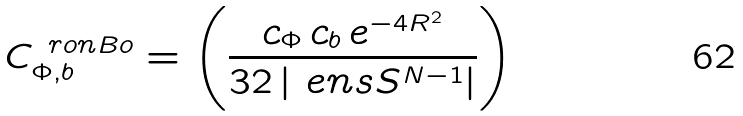<formula> <loc_0><loc_0><loc_500><loc_500>C ^ { \ r o n B o } _ { \Phi , b } = \left ( \frac { c _ { \Phi } \, c _ { b } \, e ^ { - 4 R ^ { 2 } } } { 3 2 \left | \ e n s { S } ^ { N - 1 } \right | } \right )</formula> 